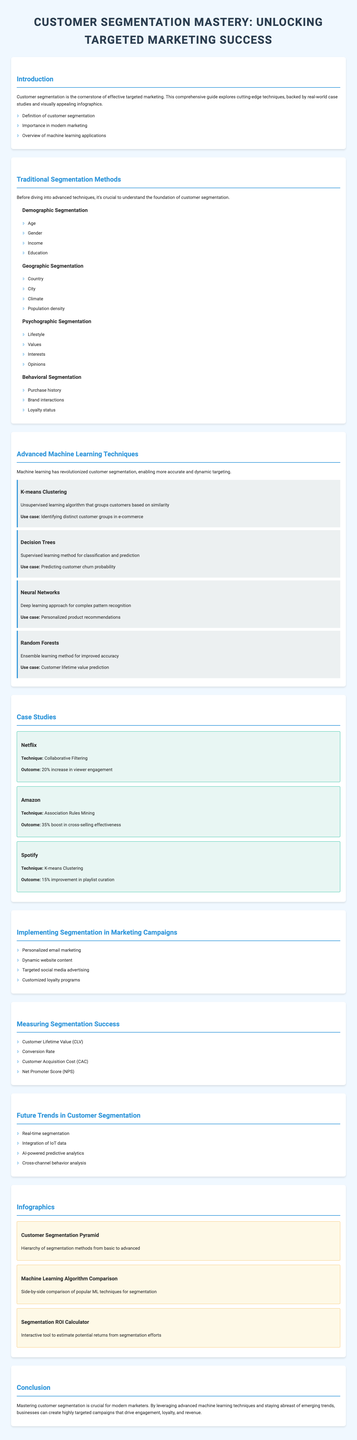What is the title of the brochure? The title is the main heading found at the top of the document, highlighting its focus on customer segmentation.
Answer: Customer Segmentation Mastery: Unlocking Targeted Marketing Success How many traditional segmentation methods are listed? The document counts the number of traditional segmentation methods discussed in the relevant section.
Answer: Four Which company is mentioned in relation to collaborative filtering? The company is provided as part of a case study demonstrating the effectiveness of a segmentation technique.
Answer: Netflix What is the outcome of Amazon's association rules mining? The outcome indicates the effectiveness achieved by Amazon through the listed segmentation technique in terms of performance metrics.
Answer: 35% boost in cross-selling effectiveness What advanced machine learning technique is used for customer lifetime value prediction? This question focuses on identifying which technique appears alongside its specific use case in the corresponding section.
Answer: Random Forests Name one trend in future customer segmentation. The document lists several future trends, and this question seeks one example.
Answer: Real-time segmentation What is one strategy for implementing segmentation in marketing campaigns? The document presents various strategies, and this question aims to extract one of them associated with the implementation of segmentation.
Answer: Personalized email marketing How much improvement did Spotify achieve in playlist curation? This outcome pertains to the effectiveness of a specific segmentation method in a case study outlined in the document.
Answer: 15% improvement in playlist curation 